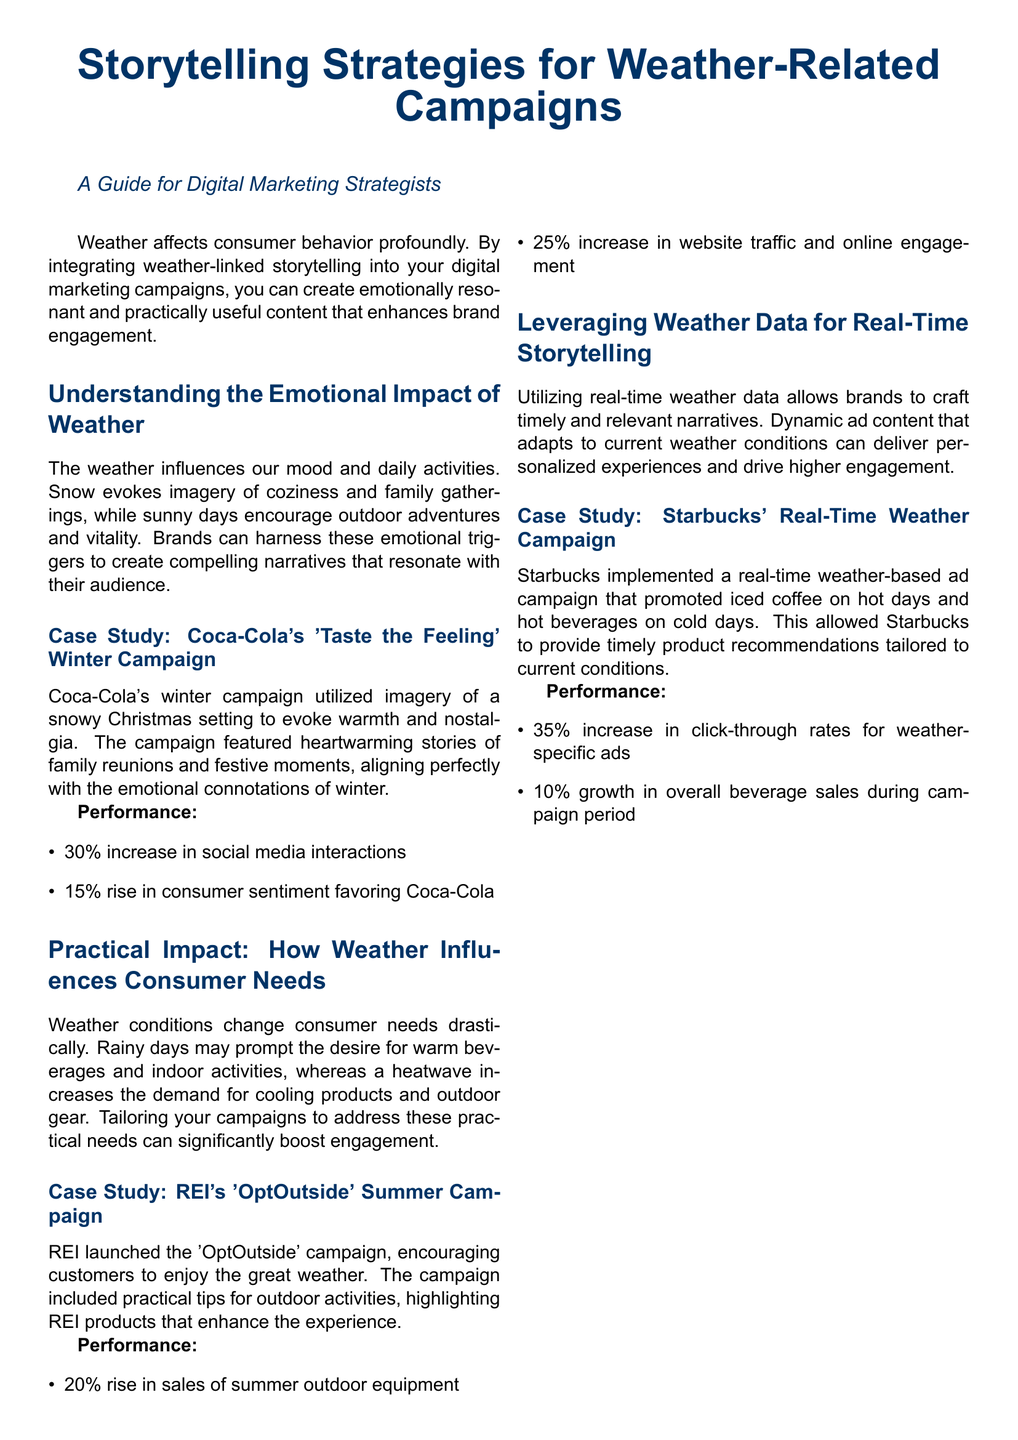What is the title of the document? The title of the document is prominently displayed at the beginning, which is "Storytelling Strategies for Weather-Related Campaigns."
Answer: Storytelling Strategies for Weather-Related Campaigns What brand is associated with the 'Taste the Feeling' winter campaign? The brand that utilized this campaign is provided in the case study section, which is Coca-Cola.
Answer: Coca-Cola What was the percentage increase in social media interactions for Coca-Cola's campaign? This information is stated in the performance section for the Coca-Cola case study, indicating a 30% increase.
Answer: 30% What emotional association does snow provoke according to the document? The document mentions that snow evokes imagery of coziness and family gatherings, addressing emotional triggers.
Answer: Coziness and family gatherings What percentage increase in sales did REI experience during their campaign? The performance section of REI's case study provides this information, stating a rise of 20%.
Answer: 20% How does Starbucks adapt its advertising to weather conditions? The document discusses how Starbucks employs real-time weather data to tailor its advertising, specifically promoting different beverages based on current weather.
Answer: Real-time weather data What is one practical need consumers have during rainy days? The document outlines consumers' desire for warm beverages and indoor activities as a practical need influenced by weather.
Answer: Warm beverages What is the performance increase for click-through rates in Starbucks' campaign? This detail is found in the performance metrics of Starbucks’ Real-Time Weather Campaign, reporting a 35% increase.
Answer: 35% What is a key benefit of leveraging weather data in campaigns? The document explains that using current weather data allows for personalized experiences and improved engagement.
Answer: Personalized experiences 